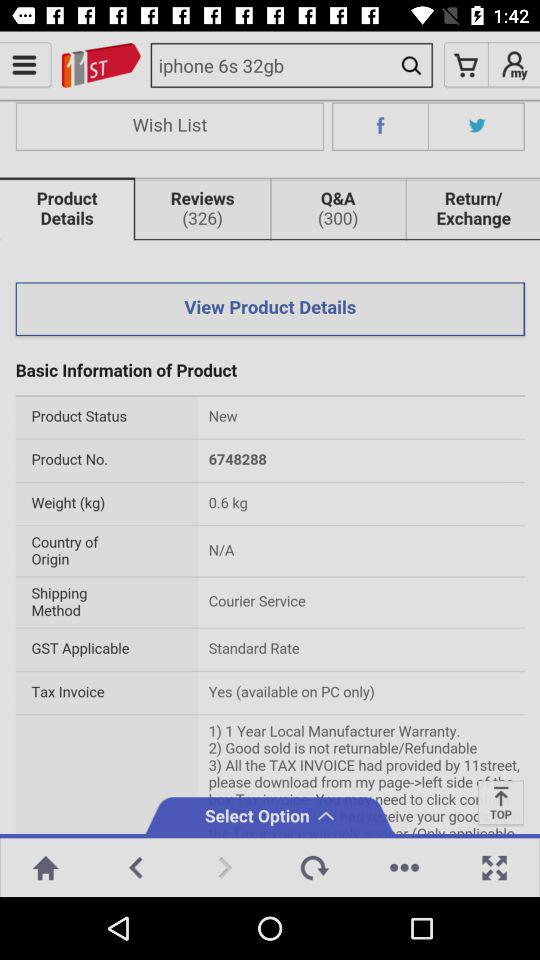How many coupons are available?
Answer the question using a single word or phrase. 2 